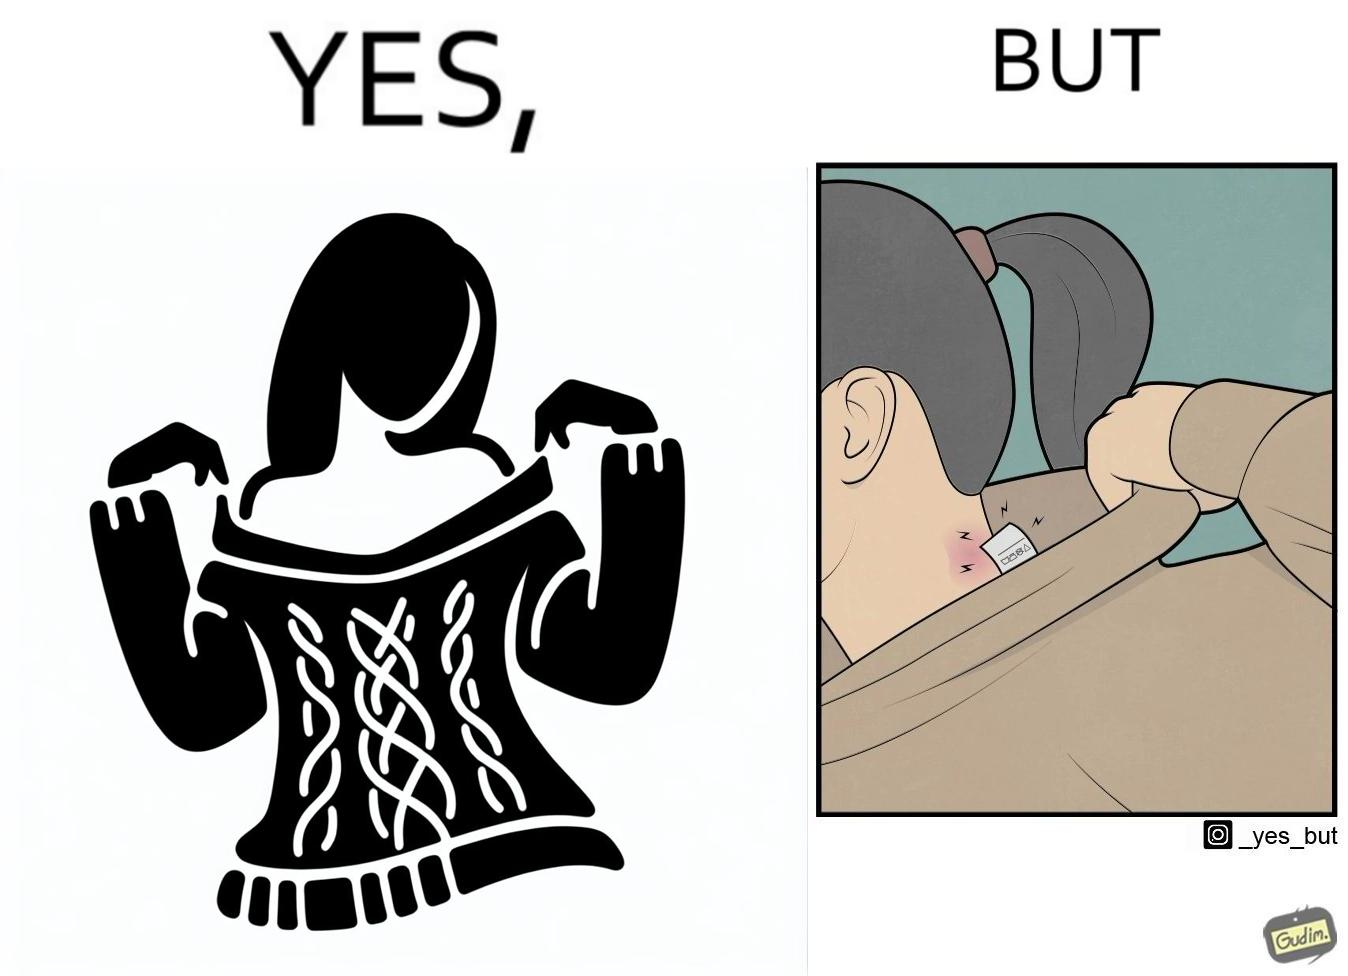Describe the content of this image. The images are funny since it shows how even though sweaters and other clothings provide much comfort, a tiny manufacturers tag ends up causing the user a lot of discomfort due to constant scratching 